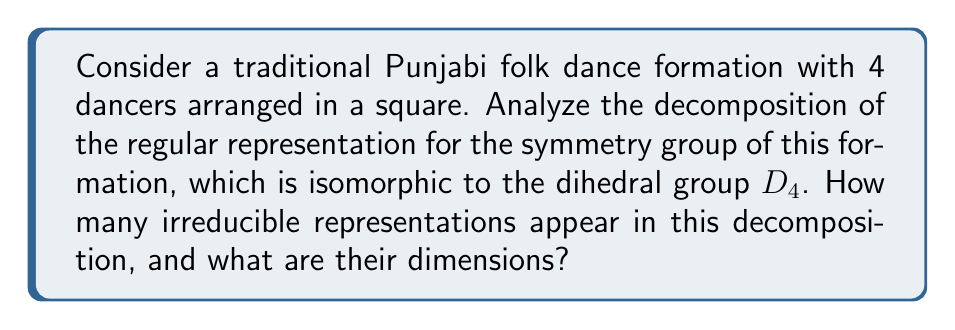Help me with this question. Let's approach this step-by-step:

1) The symmetry group of a square is isomorphic to the dihedral group $D_4$, which has 8 elements.

2) The regular representation of a group $G$ acts on the group algebra $\mathbb{C}[G]$, which has dimension $|G|$. In this case, the dimension is 8.

3) The character of the regular representation is given by:
   $$\chi_{reg}(g) = \begin{cases} 
   |G| & \text{if } g = e \\
   0 & \text{if } g \neq e
   \end{cases}$$

4) $D_4$ has 5 conjugacy classes: $\{e\}$, $\{r^2\}$, $\{r, r^3\}$, $\{s, sr^2\}$, $\{sr, sr^3\}$, where $r$ is a 90-degree rotation and $s$ is a reflection.

5) $D_4$ has 5 irreducible representations:
   - Two 1-dimensional representations: the trivial representation and the sign representation.
   - One 2-dimensional representation.
   - Two more 1-dimensional representations.

6) Let's call these representations $\rho_1, \rho_2, \rho_3, \rho_4, \rho_5$ with dimensions 1, 1, 2, 1, 1 respectively.

7) The decomposition of the regular representation is given by:
   $$\chi_{reg} = \sum_{i=1}^5 d_i \chi_i$$
   where $d_i$ is the dimension of the $i$-th irreducible representation and $\chi_i$ is its character.

8) Substituting the dimensions:
   $$\chi_{reg} = 1\chi_1 + 1\chi_2 + 2\chi_3 + 1\chi_4 + 1\chi_5$$

9) This means that in the decomposition of the regular representation, each irreducible representation appears with multiplicity equal to its dimension.

Therefore, all 5 irreducible representations of $D_4$ appear in the decomposition of the regular representation.
Answer: 5 irreducible representations: two of dimension 2 and three of dimension 1 